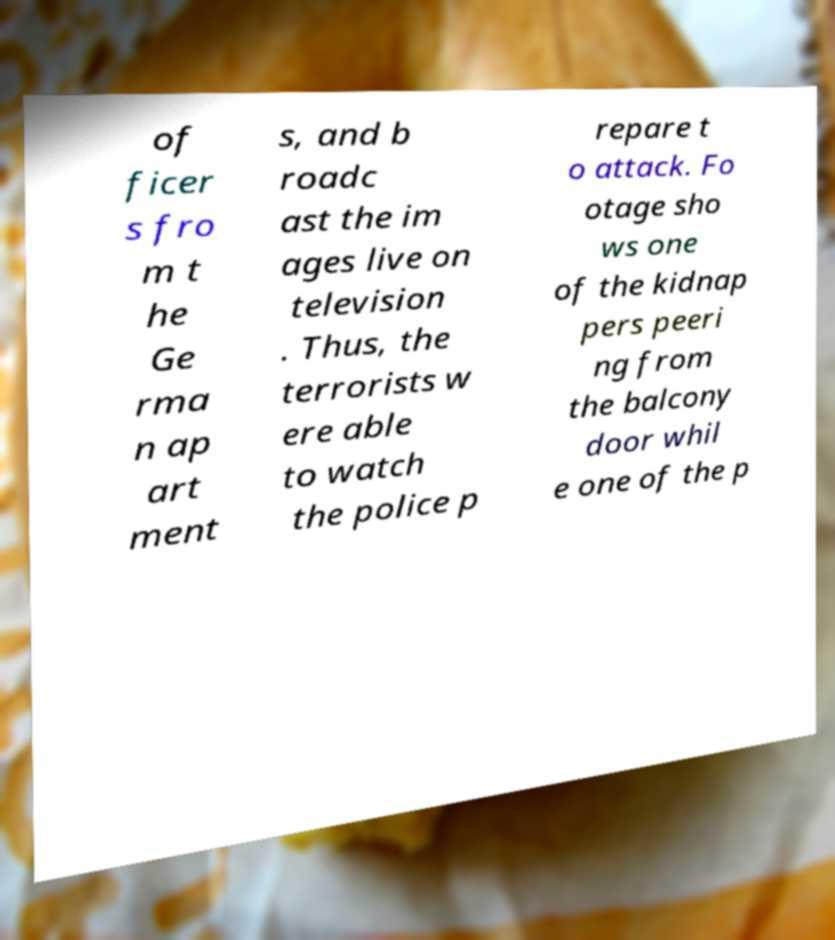What messages or text are displayed in this image? I need them in a readable, typed format. of ficer s fro m t he Ge rma n ap art ment s, and b roadc ast the im ages live on television . Thus, the terrorists w ere able to watch the police p repare t o attack. Fo otage sho ws one of the kidnap pers peeri ng from the balcony door whil e one of the p 